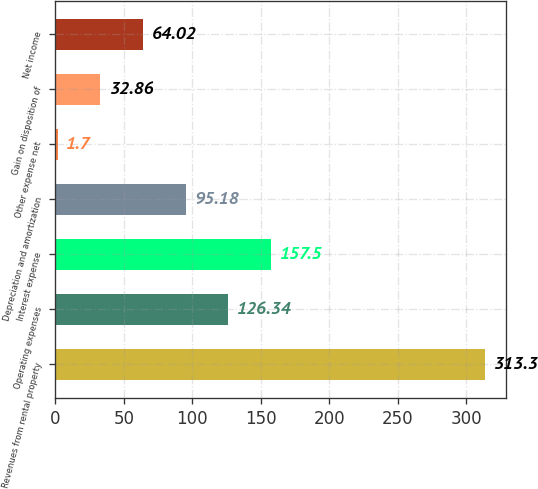<chart> <loc_0><loc_0><loc_500><loc_500><bar_chart><fcel>Revenues from rental property<fcel>Operating expenses<fcel>Interest expense<fcel>Depreciation and amortization<fcel>Other expense net<fcel>Gain on disposition of<fcel>Net income<nl><fcel>313.3<fcel>126.34<fcel>157.5<fcel>95.18<fcel>1.7<fcel>32.86<fcel>64.02<nl></chart> 